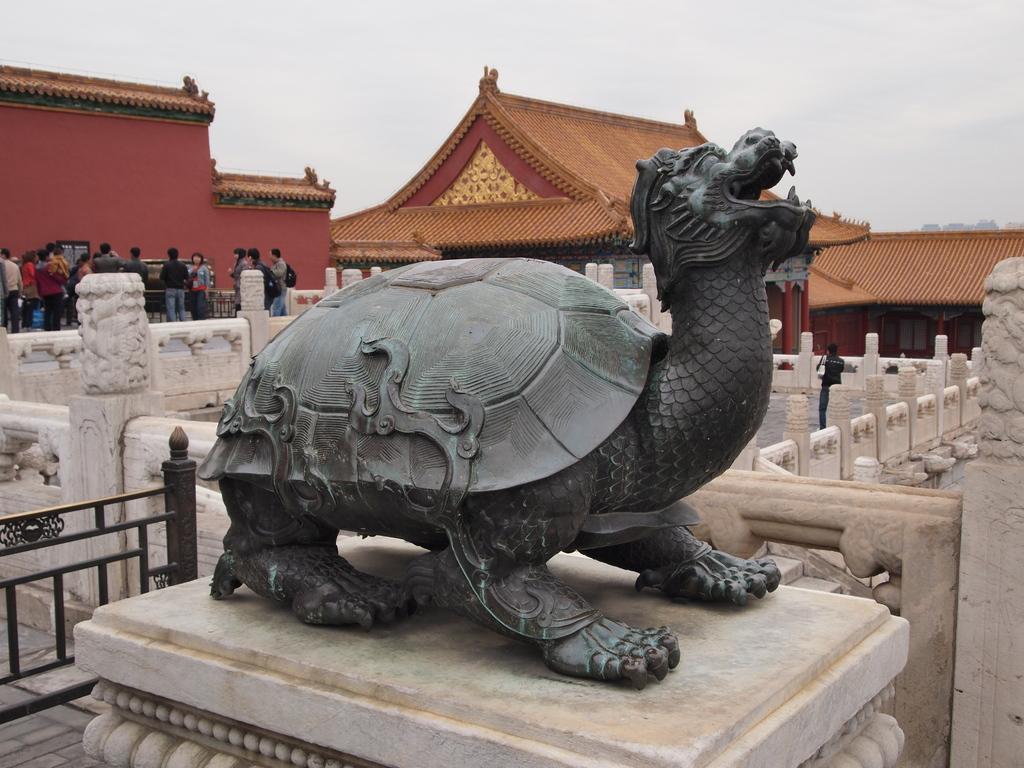Please provide a concise description of this image. In the foreground of the image there is a statue of an animal. In the background of the image there are houses. There are people standing. There is wall. At the top of the image there is sky. To the left side of the image there is a railing. 